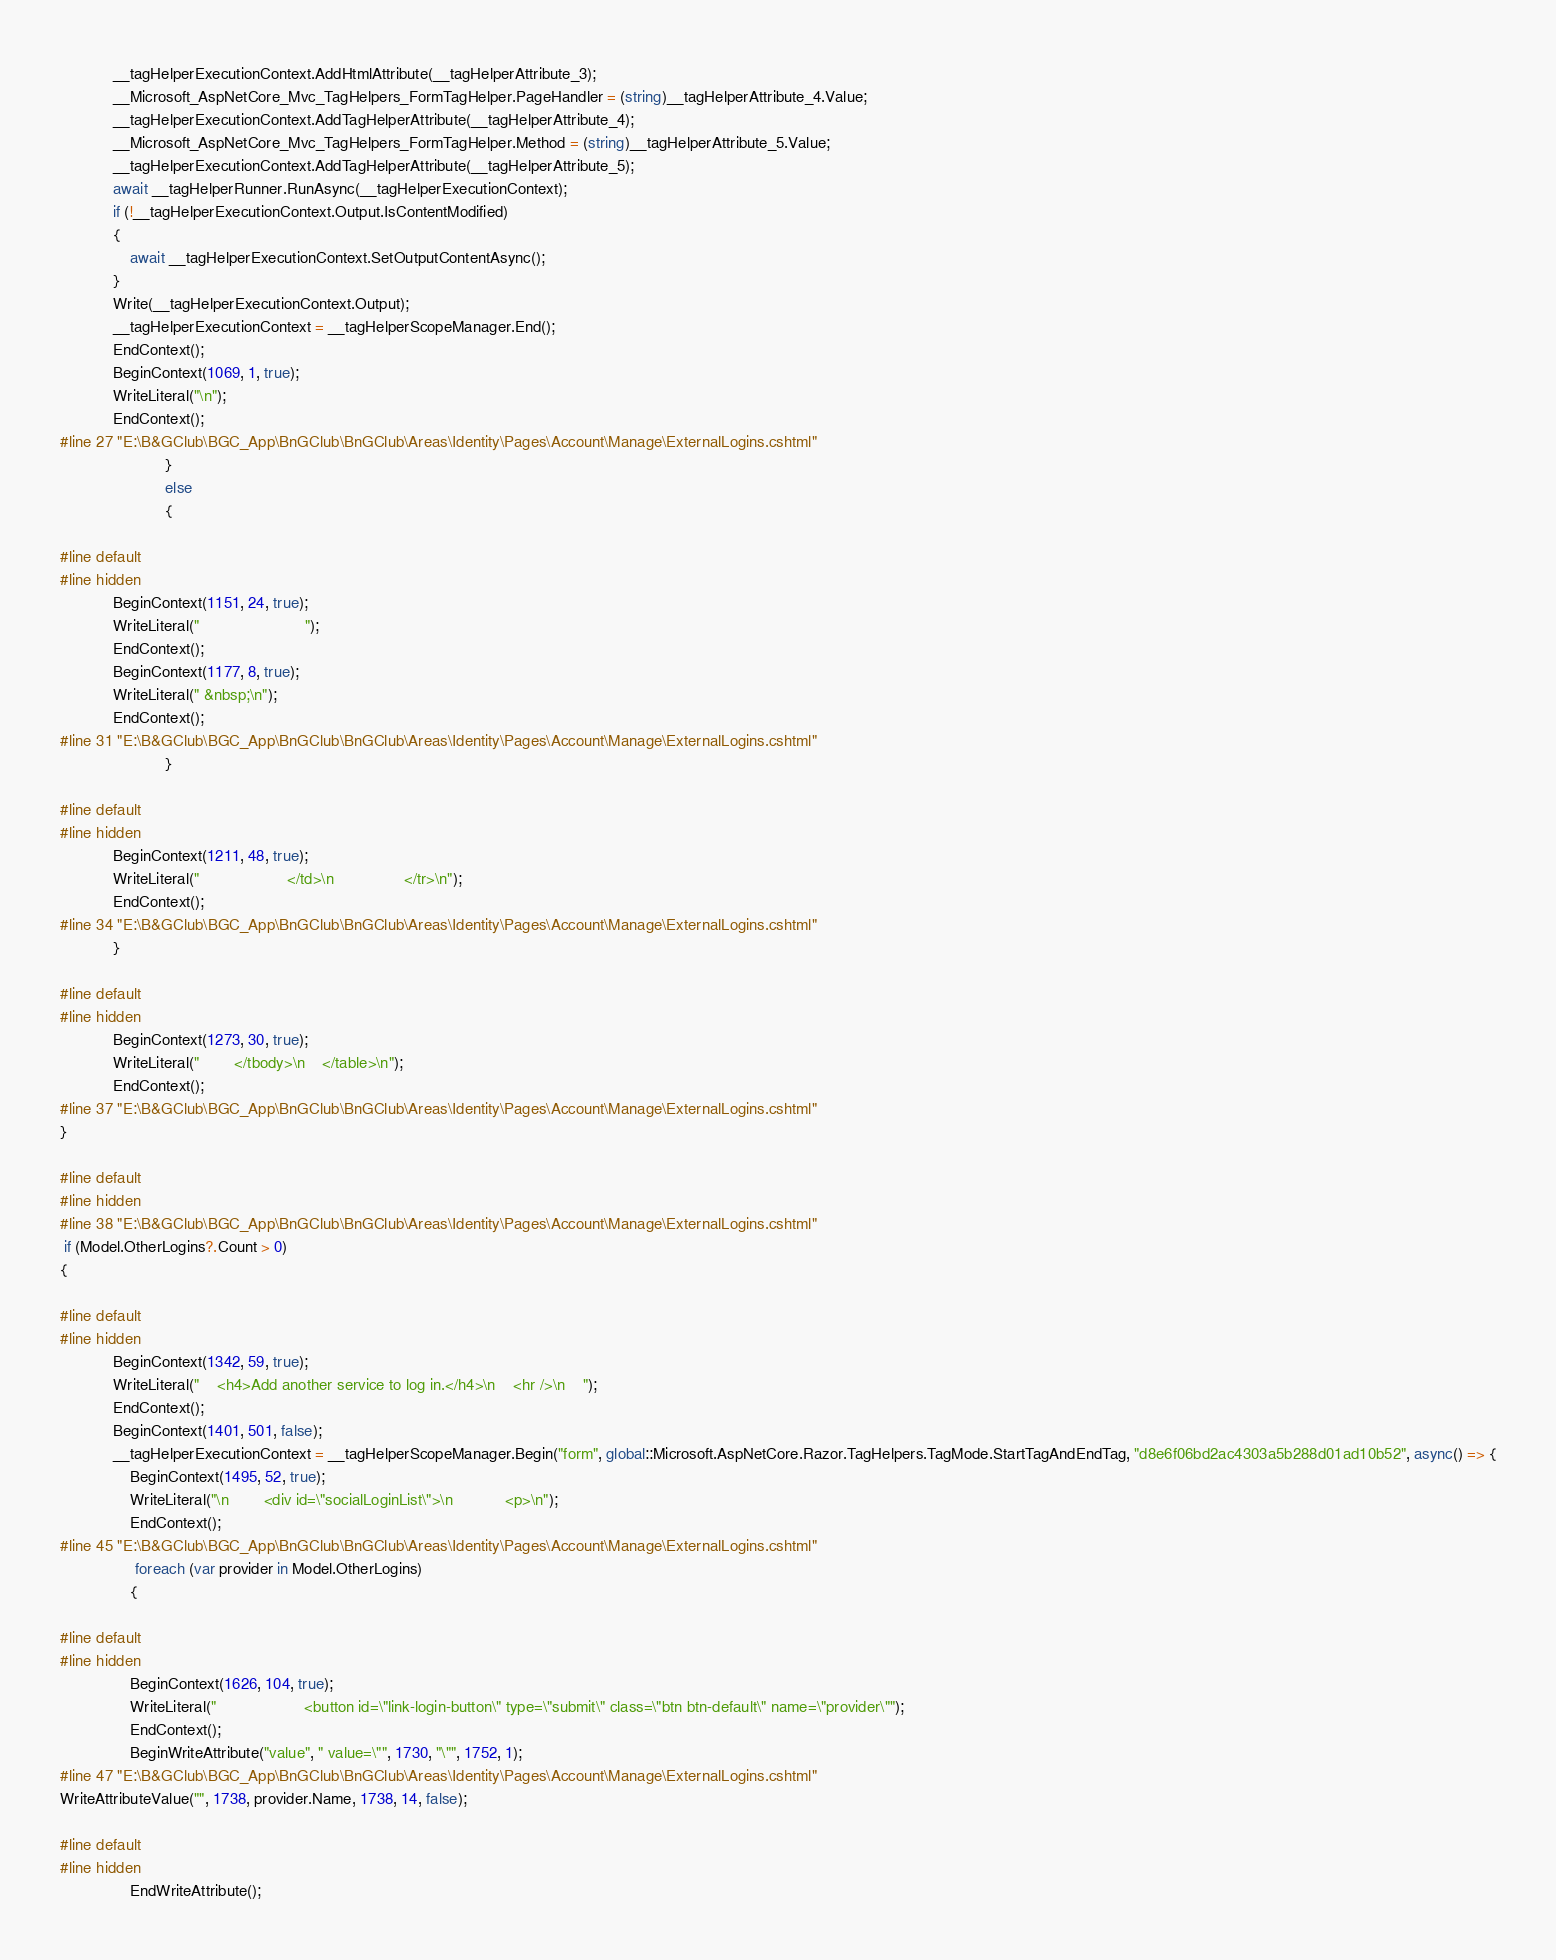Convert code to text. <code><loc_0><loc_0><loc_500><loc_500><_C#_>            __tagHelperExecutionContext.AddHtmlAttribute(__tagHelperAttribute_3);
            __Microsoft_AspNetCore_Mvc_TagHelpers_FormTagHelper.PageHandler = (string)__tagHelperAttribute_4.Value;
            __tagHelperExecutionContext.AddTagHelperAttribute(__tagHelperAttribute_4);
            __Microsoft_AspNetCore_Mvc_TagHelpers_FormTagHelper.Method = (string)__tagHelperAttribute_5.Value;
            __tagHelperExecutionContext.AddTagHelperAttribute(__tagHelperAttribute_5);
            await __tagHelperRunner.RunAsync(__tagHelperExecutionContext);
            if (!__tagHelperExecutionContext.Output.IsContentModified)
            {
                await __tagHelperExecutionContext.SetOutputContentAsync();
            }
            Write(__tagHelperExecutionContext.Output);
            __tagHelperExecutionContext = __tagHelperScopeManager.End();
            EndContext();
            BeginContext(1069, 1, true);
            WriteLiteral("\n");
            EndContext();
#line 27 "E:\B&GClub\BGC_App\BnGClub\BnGClub\Areas\Identity\Pages\Account\Manage\ExternalLogins.cshtml"
                        }
                        else
                        {

#line default
#line hidden
            BeginContext(1151, 24, true);
            WriteLiteral("                        ");
            EndContext();
            BeginContext(1177, 8, true);
            WriteLiteral(" &nbsp;\n");
            EndContext();
#line 31 "E:\B&GClub\BGC_App\BnGClub\BnGClub\Areas\Identity\Pages\Account\Manage\ExternalLogins.cshtml"
                        }

#line default
#line hidden
            BeginContext(1211, 48, true);
            WriteLiteral("                    </td>\n                </tr>\n");
            EndContext();
#line 34 "E:\B&GClub\BGC_App\BnGClub\BnGClub\Areas\Identity\Pages\Account\Manage\ExternalLogins.cshtml"
            }

#line default
#line hidden
            BeginContext(1273, 30, true);
            WriteLiteral("        </tbody>\n    </table>\n");
            EndContext();
#line 37 "E:\B&GClub\BGC_App\BnGClub\BnGClub\Areas\Identity\Pages\Account\Manage\ExternalLogins.cshtml"
}

#line default
#line hidden
#line 38 "E:\B&GClub\BGC_App\BnGClub\BnGClub\Areas\Identity\Pages\Account\Manage\ExternalLogins.cshtml"
 if (Model.OtherLogins?.Count > 0)
{

#line default
#line hidden
            BeginContext(1342, 59, true);
            WriteLiteral("    <h4>Add another service to log in.</h4>\n    <hr />\n    ");
            EndContext();
            BeginContext(1401, 501, false);
            __tagHelperExecutionContext = __tagHelperScopeManager.Begin("form", global::Microsoft.AspNetCore.Razor.TagHelpers.TagMode.StartTagAndEndTag, "d8e6f06bd2ac4303a5b288d01ad10b52", async() => {
                BeginContext(1495, 52, true);
                WriteLiteral("\n        <div id=\"socialLoginList\">\n            <p>\n");
                EndContext();
#line 45 "E:\B&GClub\BGC_App\BnGClub\BnGClub\Areas\Identity\Pages\Account\Manage\ExternalLogins.cshtml"
                 foreach (var provider in Model.OtherLogins)
                {

#line default
#line hidden
                BeginContext(1626, 104, true);
                WriteLiteral("                    <button id=\"link-login-button\" type=\"submit\" class=\"btn btn-default\" name=\"provider\"");
                EndContext();
                BeginWriteAttribute("value", " value=\"", 1730, "\"", 1752, 1);
#line 47 "E:\B&GClub\BGC_App\BnGClub\BnGClub\Areas\Identity\Pages\Account\Manage\ExternalLogins.cshtml"
WriteAttributeValue("", 1738, provider.Name, 1738, 14, false);

#line default
#line hidden
                EndWriteAttribute();</code> 